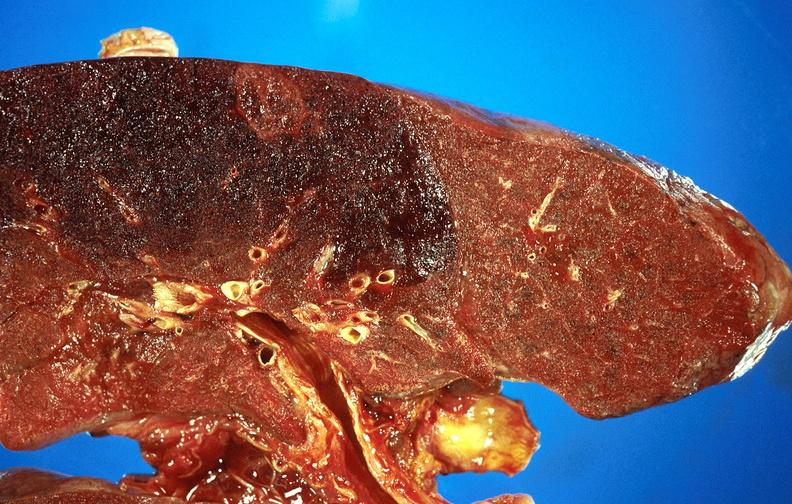does this image show subacute pulmonary thromboembolus with acute infarct?
Answer the question using a single word or phrase. Yes 